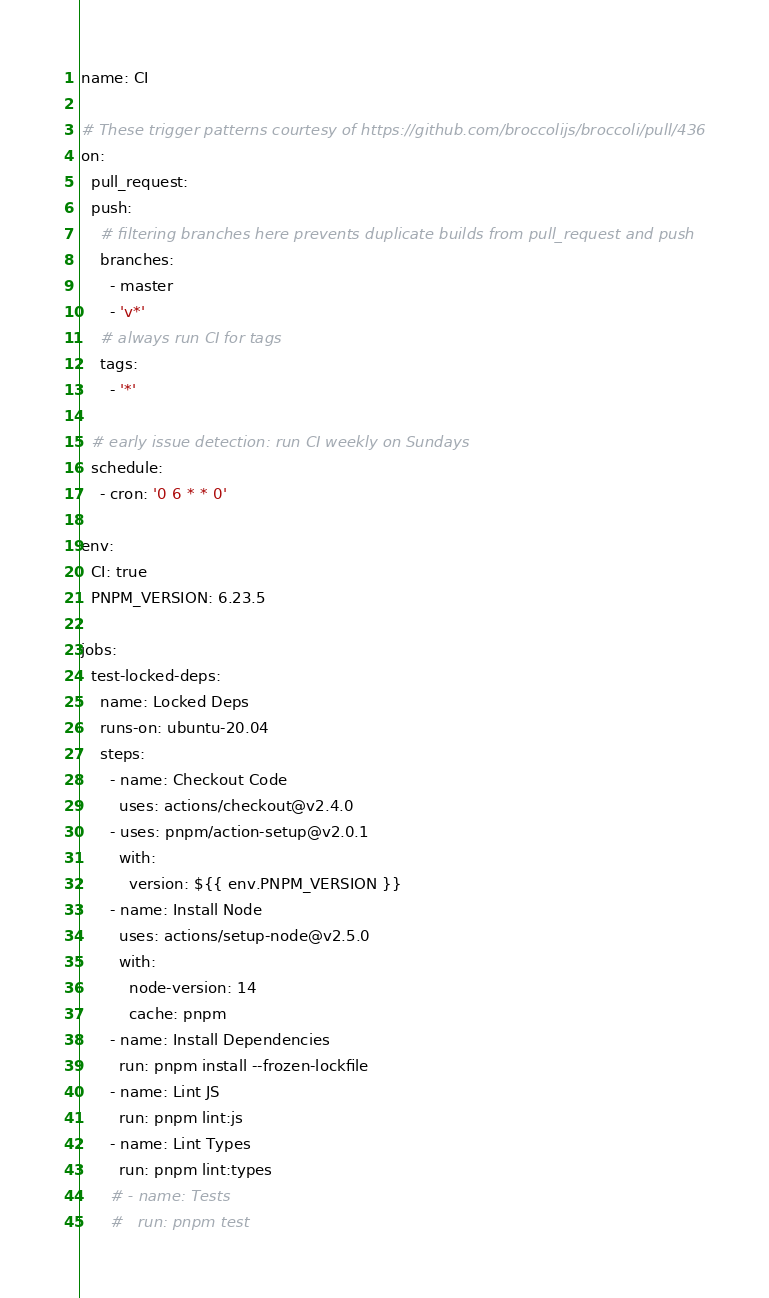<code> <loc_0><loc_0><loc_500><loc_500><_YAML_>name: CI

# These trigger patterns courtesy of https://github.com/broccolijs/broccoli/pull/436
on:
  pull_request:
  push:
    # filtering branches here prevents duplicate builds from pull_request and push
    branches:
      - master
      - 'v*'
    # always run CI for tags
    tags:
      - '*'

  # early issue detection: run CI weekly on Sundays
  schedule:
    - cron: '0 6 * * 0'

env:
  CI: true
  PNPM_VERSION: 6.23.5

jobs:
  test-locked-deps:
    name: Locked Deps
    runs-on: ubuntu-20.04
    steps:
      - name: Checkout Code
        uses: actions/checkout@v2.4.0
      - uses: pnpm/action-setup@v2.0.1
        with:
          version: ${{ env.PNPM_VERSION }}
      - name: Install Node
        uses: actions/setup-node@v2.5.0
        with:
          node-version: 14
          cache: pnpm
      - name: Install Dependencies
        run: pnpm install --frozen-lockfile
      - name: Lint JS
        run: pnpm lint:js
      - name: Lint Types
        run: pnpm lint:types
      # - name: Tests
      #   run: pnpm test
</code> 